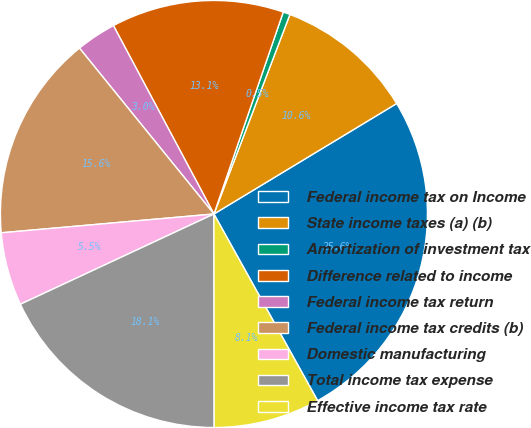Convert chart to OTSL. <chart><loc_0><loc_0><loc_500><loc_500><pie_chart><fcel>Federal income tax on Income<fcel>State income taxes (a) (b)<fcel>Amortization of investment tax<fcel>Difference related to income<fcel>Federal income tax return<fcel>Federal income tax credits (b)<fcel>Domestic manufacturing<fcel>Total income tax expense<fcel>Effective income tax rate<nl><fcel>25.58%<fcel>10.55%<fcel>0.53%<fcel>13.06%<fcel>3.04%<fcel>15.56%<fcel>5.54%<fcel>18.07%<fcel>8.05%<nl></chart> 